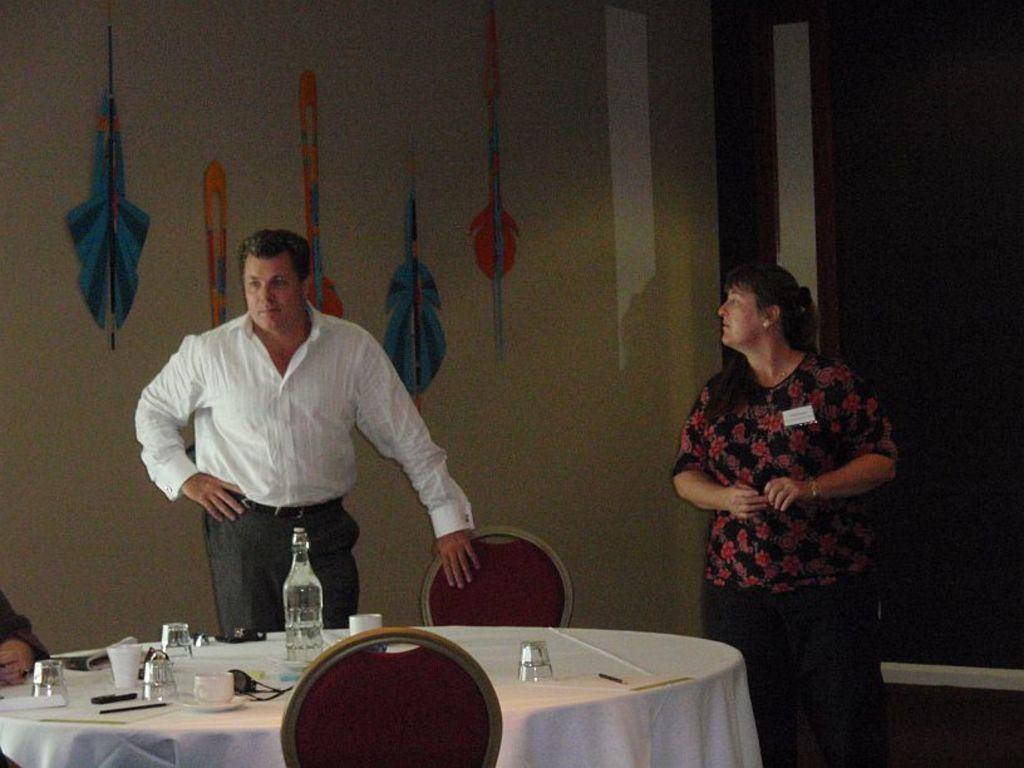How many people are in the image? There is a man and a woman in the image. What are the man and woman doing in the image? The man and woman are standing beside each other. What is on the table in the image? There are glasses and bottles on the table. Is there any furniture or object attached to the wall in the image? Yes, there is a wall hanger in the image. What type of card is the man holding in the image? There is no card present in the image; the man is not holding anything. 